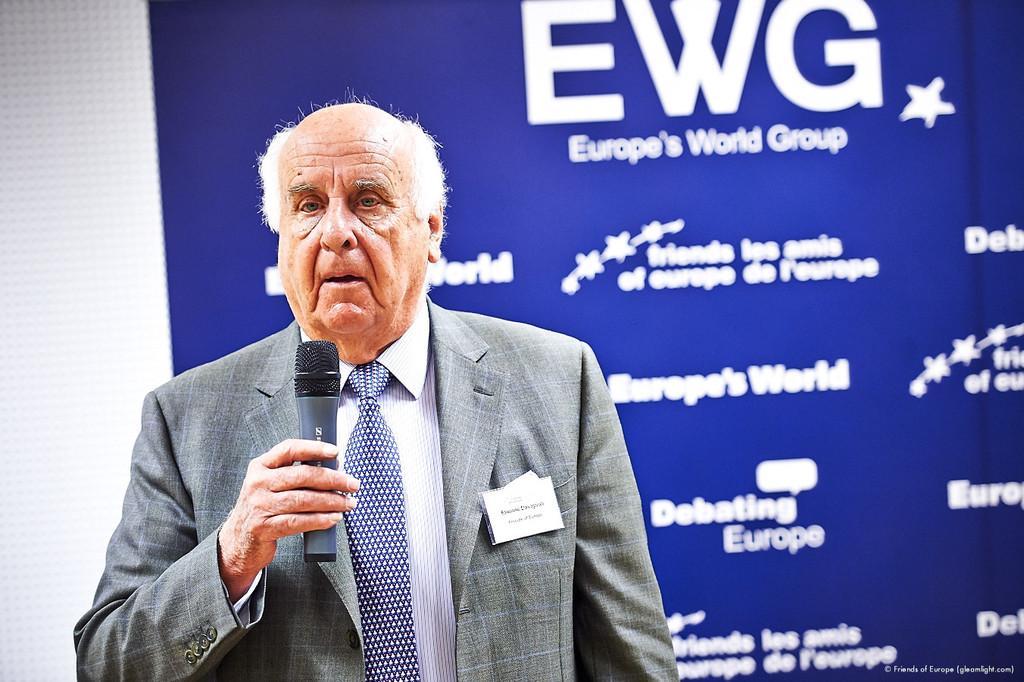How would you summarize this image in a sentence or two? This picture is of inside. In the center there is a man wearing suit, holding a microphone, standing and seems to be talking. In the background we can see a wall and a banner on which the text is printed. 